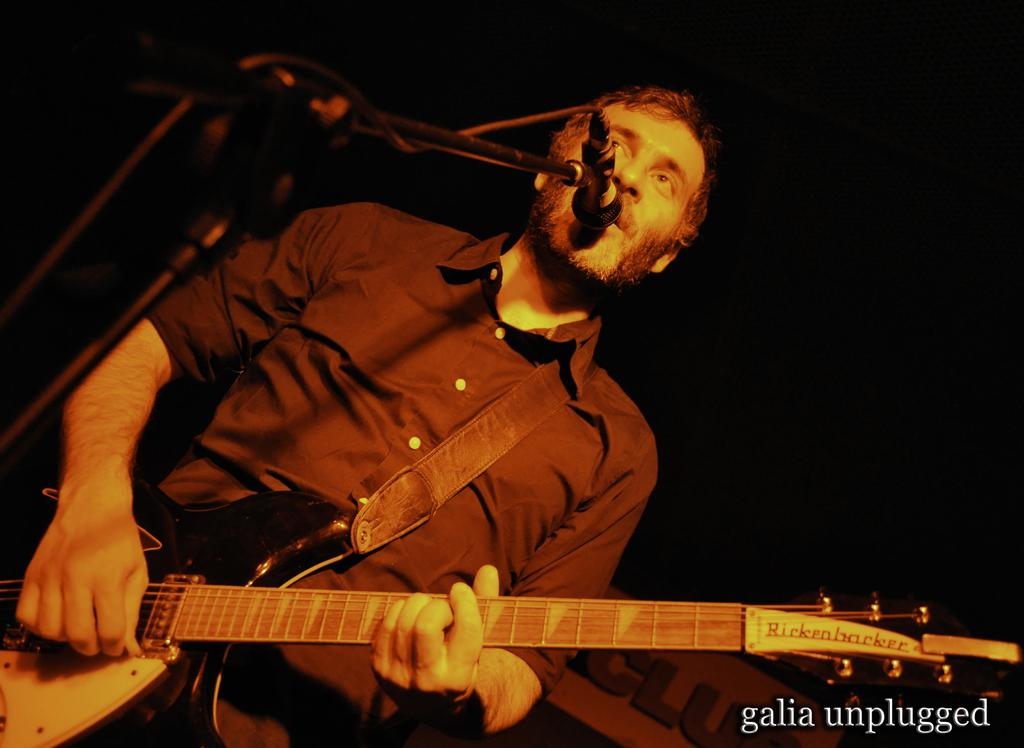Who or what is present in the image? There is a person in the image. What is the person doing in the image? The person is standing in the image. What object is the person holding in the image? The person is holding a guitar in the image. What other object can be seen in the image related to performing? There is a microphone with a stand in the image. What type of sponge can be seen cleaning the guitar in the image? There is no sponge present in the image, nor is there any indication of the guitar being cleaned. 